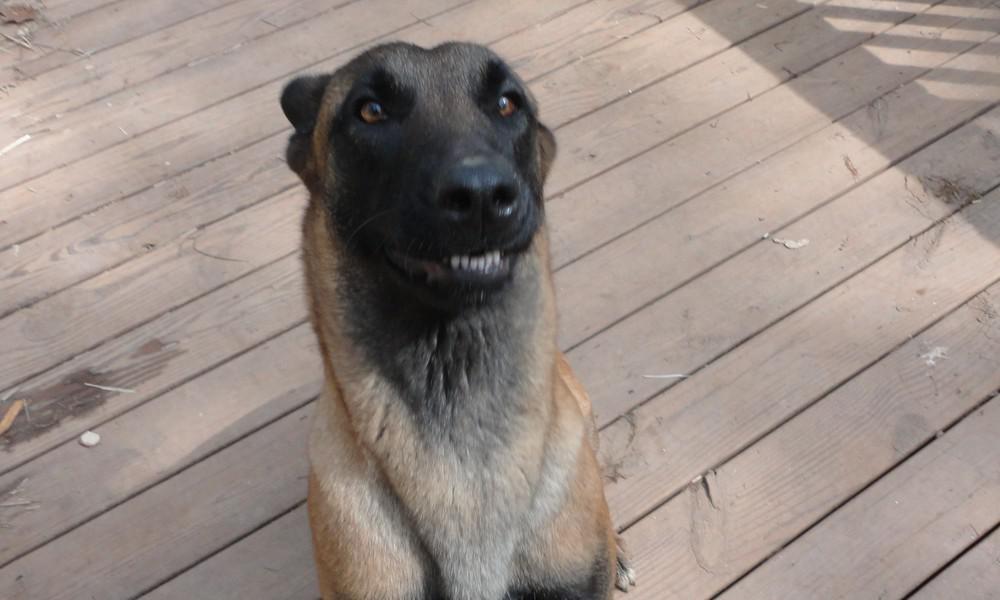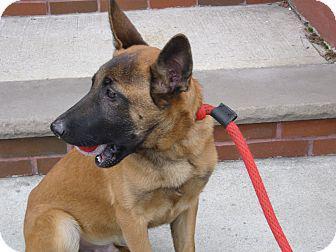The first image is the image on the left, the second image is the image on the right. For the images shown, is this caption "The dog in the right image is sitting upright, with head turned leftward." true? Answer yes or no. Yes. The first image is the image on the left, the second image is the image on the right. Given the left and right images, does the statement "None of the dogs has their mouths open." hold true? Answer yes or no. No. 